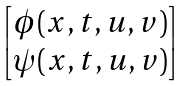Convert formula to latex. <formula><loc_0><loc_0><loc_500><loc_500>\begin{bmatrix} \phi ( x , t , u , v ) \\ \psi ( x , t , u , v ) \end{bmatrix}</formula> 